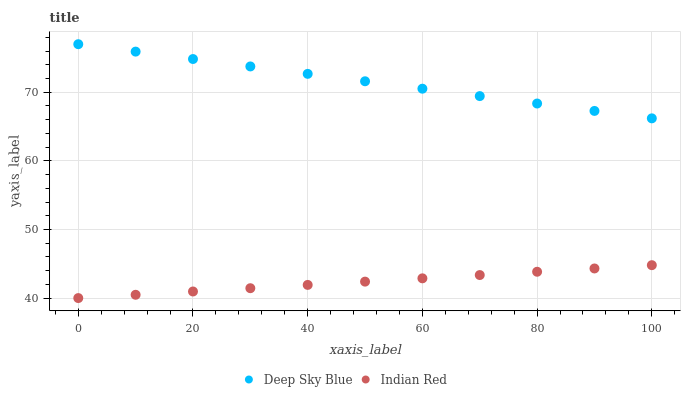Does Indian Red have the minimum area under the curve?
Answer yes or no. Yes. Does Deep Sky Blue have the maximum area under the curve?
Answer yes or no. Yes. Does Deep Sky Blue have the minimum area under the curve?
Answer yes or no. No. Is Indian Red the smoothest?
Answer yes or no. Yes. Is Deep Sky Blue the roughest?
Answer yes or no. Yes. Is Deep Sky Blue the smoothest?
Answer yes or no. No. Does Indian Red have the lowest value?
Answer yes or no. Yes. Does Deep Sky Blue have the lowest value?
Answer yes or no. No. Does Deep Sky Blue have the highest value?
Answer yes or no. Yes. Is Indian Red less than Deep Sky Blue?
Answer yes or no. Yes. Is Deep Sky Blue greater than Indian Red?
Answer yes or no. Yes. Does Indian Red intersect Deep Sky Blue?
Answer yes or no. No. 